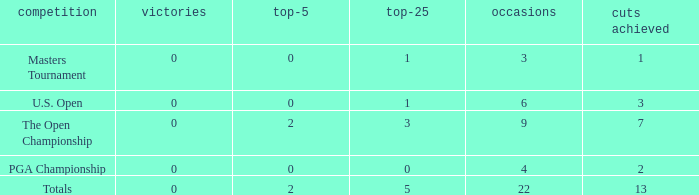How many total cuts were made in events with more than 0 wins and exactly 0 top-5s? 0.0. 